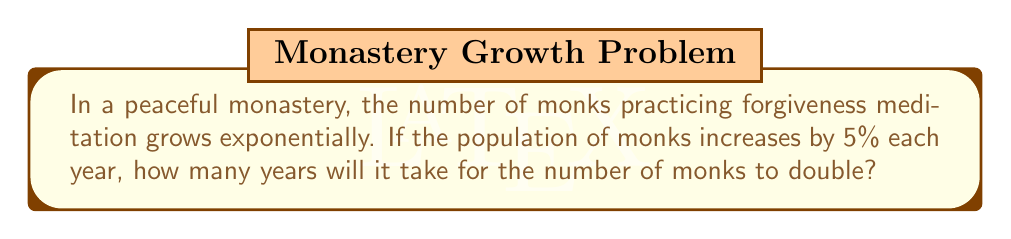Teach me how to tackle this problem. Let's approach this step-by-step using the exponential growth formula and the concept of doubling time:

1) The exponential growth formula is:
   $A = P(1 + r)^t$
   Where A is the final amount, P is the initial amount, r is the growth rate, and t is time.

2) For doubling, we want A = 2P. So our equation becomes:
   $2P = P(1 + 0.05)^t$

3) Simplify by dividing both sides by P:
   $2 = (1.05)^t$

4) Now, we can use logarithms to solve for t. Take the natural log of both sides:
   $\ln(2) = \ln((1.05)^t)$

5) Using the logarithm property $\ln(a^b) = b\ln(a)$, we get:
   $\ln(2) = t\ln(1.05)$

6) Solve for t:
   $t = \frac{\ln(2)}{\ln(1.05)}$

7) Calculate:
   $t = \frac{0.693147...}{0.048790...} \approx 14.2067...$

8) Since we're dealing with whole years, we round up to the next integer.
Answer: 15 years 